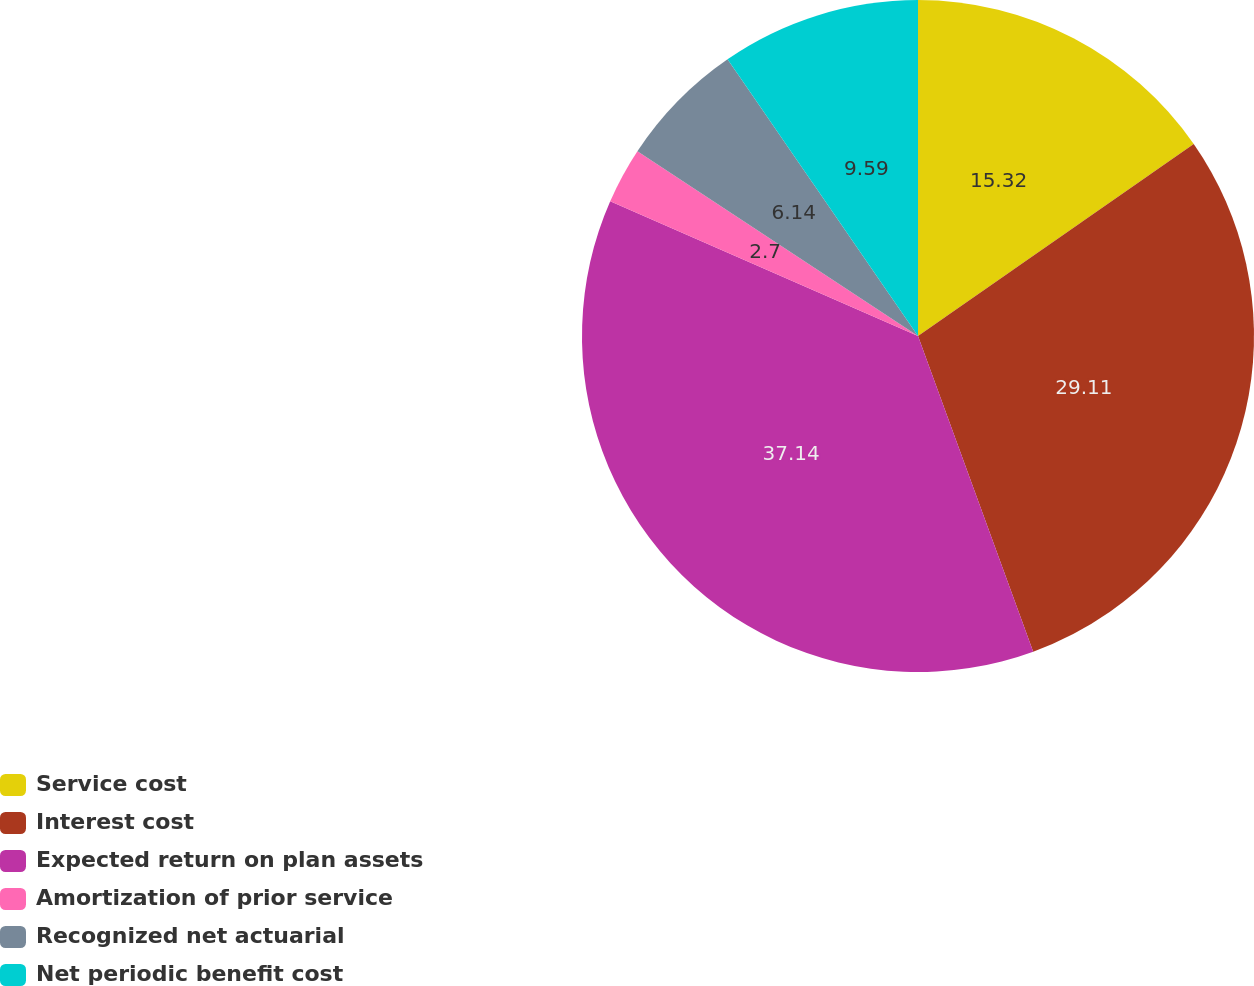Convert chart. <chart><loc_0><loc_0><loc_500><loc_500><pie_chart><fcel>Service cost<fcel>Interest cost<fcel>Expected return on plan assets<fcel>Amortization of prior service<fcel>Recognized net actuarial<fcel>Net periodic benefit cost<nl><fcel>15.32%<fcel>29.11%<fcel>37.14%<fcel>2.7%<fcel>6.14%<fcel>9.59%<nl></chart> 